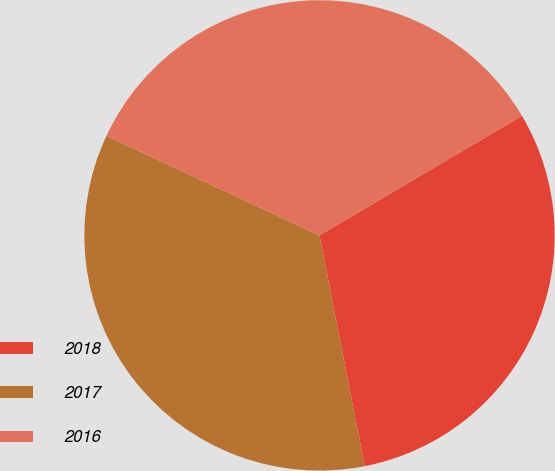<chart> <loc_0><loc_0><loc_500><loc_500><pie_chart><fcel>2018<fcel>2017<fcel>2016<nl><fcel>30.41%<fcel>35.04%<fcel>34.55%<nl></chart> 